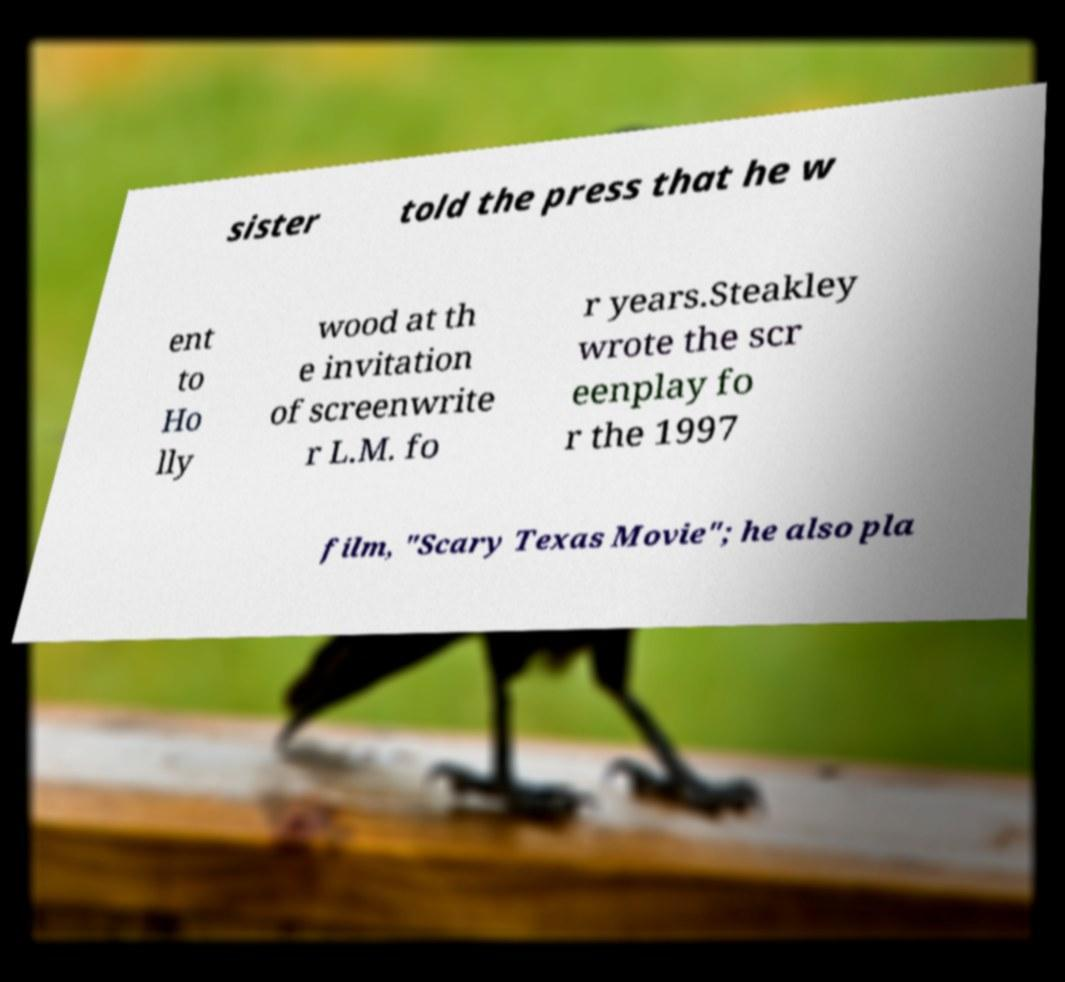Please identify and transcribe the text found in this image. sister told the press that he w ent to Ho lly wood at th e invitation of screenwrite r L.M. fo r years.Steakley wrote the scr eenplay fo r the 1997 film, "Scary Texas Movie"; he also pla 